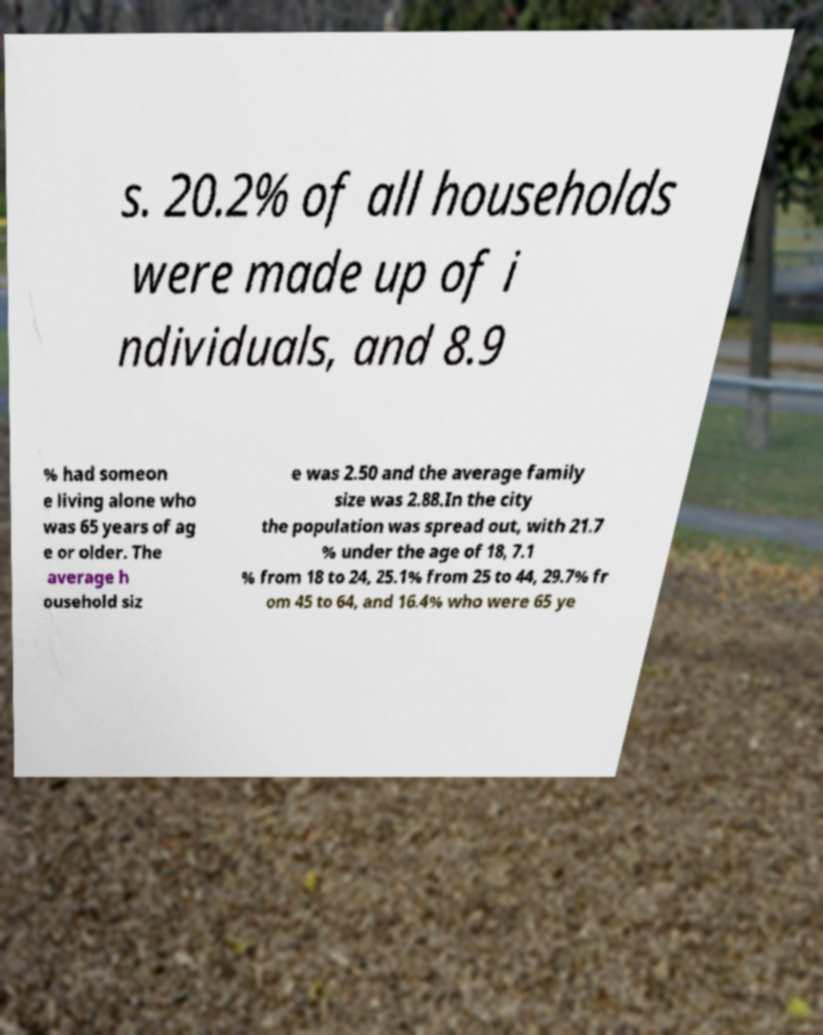Please identify and transcribe the text found in this image. s. 20.2% of all households were made up of i ndividuals, and 8.9 % had someon e living alone who was 65 years of ag e or older. The average h ousehold siz e was 2.50 and the average family size was 2.88.In the city the population was spread out, with 21.7 % under the age of 18, 7.1 % from 18 to 24, 25.1% from 25 to 44, 29.7% fr om 45 to 64, and 16.4% who were 65 ye 